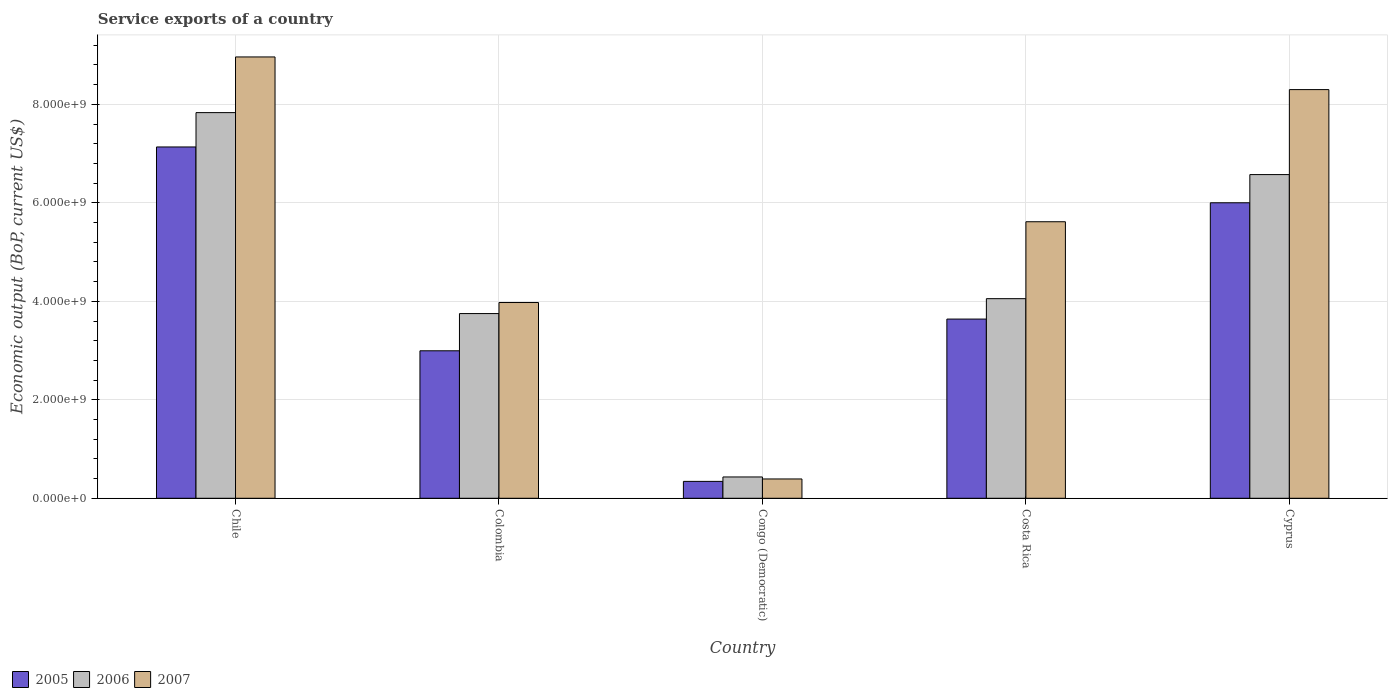How many different coloured bars are there?
Your answer should be very brief. 3. Are the number of bars per tick equal to the number of legend labels?
Provide a succinct answer. Yes. How many bars are there on the 4th tick from the left?
Your answer should be very brief. 3. How many bars are there on the 2nd tick from the right?
Make the answer very short. 3. What is the label of the 5th group of bars from the left?
Keep it short and to the point. Cyprus. In how many cases, is the number of bars for a given country not equal to the number of legend labels?
Give a very brief answer. 0. What is the service exports in 2005 in Cyprus?
Make the answer very short. 6.00e+09. Across all countries, what is the maximum service exports in 2005?
Provide a succinct answer. 7.13e+09. Across all countries, what is the minimum service exports in 2007?
Your answer should be very brief. 3.92e+08. In which country was the service exports in 2005 minimum?
Provide a short and direct response. Congo (Democratic). What is the total service exports in 2007 in the graph?
Offer a very short reply. 2.72e+1. What is the difference between the service exports in 2006 in Colombia and that in Cyprus?
Offer a terse response. -2.82e+09. What is the difference between the service exports in 2007 in Chile and the service exports in 2005 in Cyprus?
Keep it short and to the point. 2.96e+09. What is the average service exports in 2006 per country?
Offer a terse response. 4.53e+09. What is the difference between the service exports of/in 2007 and service exports of/in 2006 in Colombia?
Offer a very short reply. 2.24e+08. In how many countries, is the service exports in 2007 greater than 3200000000 US$?
Your response must be concise. 4. What is the ratio of the service exports in 2007 in Congo (Democratic) to that in Cyprus?
Keep it short and to the point. 0.05. Is the service exports in 2007 in Congo (Democratic) less than that in Cyprus?
Provide a short and direct response. Yes. What is the difference between the highest and the second highest service exports in 2007?
Offer a terse response. 6.63e+08. What is the difference between the highest and the lowest service exports in 2007?
Provide a succinct answer. 8.57e+09. Is the sum of the service exports in 2005 in Congo (Democratic) and Costa Rica greater than the maximum service exports in 2006 across all countries?
Ensure brevity in your answer.  No. Is it the case that in every country, the sum of the service exports in 2006 and service exports in 2005 is greater than the service exports in 2007?
Provide a short and direct response. Yes. How many bars are there?
Keep it short and to the point. 15. Where does the legend appear in the graph?
Make the answer very short. Bottom left. How are the legend labels stacked?
Offer a terse response. Horizontal. What is the title of the graph?
Keep it short and to the point. Service exports of a country. What is the label or title of the Y-axis?
Provide a short and direct response. Economic output (BoP, current US$). What is the Economic output (BoP, current US$) in 2005 in Chile?
Ensure brevity in your answer.  7.13e+09. What is the Economic output (BoP, current US$) in 2006 in Chile?
Ensure brevity in your answer.  7.83e+09. What is the Economic output (BoP, current US$) in 2007 in Chile?
Provide a short and direct response. 8.96e+09. What is the Economic output (BoP, current US$) in 2005 in Colombia?
Offer a very short reply. 3.00e+09. What is the Economic output (BoP, current US$) of 2006 in Colombia?
Offer a terse response. 3.75e+09. What is the Economic output (BoP, current US$) in 2007 in Colombia?
Give a very brief answer. 3.98e+09. What is the Economic output (BoP, current US$) in 2005 in Congo (Democratic)?
Offer a very short reply. 3.43e+08. What is the Economic output (BoP, current US$) in 2006 in Congo (Democratic)?
Provide a short and direct response. 4.33e+08. What is the Economic output (BoP, current US$) in 2007 in Congo (Democratic)?
Give a very brief answer. 3.92e+08. What is the Economic output (BoP, current US$) of 2005 in Costa Rica?
Give a very brief answer. 3.64e+09. What is the Economic output (BoP, current US$) in 2006 in Costa Rica?
Your response must be concise. 4.05e+09. What is the Economic output (BoP, current US$) in 2007 in Costa Rica?
Offer a terse response. 5.62e+09. What is the Economic output (BoP, current US$) of 2005 in Cyprus?
Make the answer very short. 6.00e+09. What is the Economic output (BoP, current US$) in 2006 in Cyprus?
Your response must be concise. 6.57e+09. What is the Economic output (BoP, current US$) in 2007 in Cyprus?
Ensure brevity in your answer.  8.30e+09. Across all countries, what is the maximum Economic output (BoP, current US$) in 2005?
Provide a succinct answer. 7.13e+09. Across all countries, what is the maximum Economic output (BoP, current US$) of 2006?
Ensure brevity in your answer.  7.83e+09. Across all countries, what is the maximum Economic output (BoP, current US$) in 2007?
Make the answer very short. 8.96e+09. Across all countries, what is the minimum Economic output (BoP, current US$) of 2005?
Provide a succinct answer. 3.43e+08. Across all countries, what is the minimum Economic output (BoP, current US$) in 2006?
Provide a short and direct response. 4.33e+08. Across all countries, what is the minimum Economic output (BoP, current US$) of 2007?
Make the answer very short. 3.92e+08. What is the total Economic output (BoP, current US$) of 2005 in the graph?
Keep it short and to the point. 2.01e+1. What is the total Economic output (BoP, current US$) in 2006 in the graph?
Offer a terse response. 2.26e+1. What is the total Economic output (BoP, current US$) in 2007 in the graph?
Ensure brevity in your answer.  2.72e+1. What is the difference between the Economic output (BoP, current US$) in 2005 in Chile and that in Colombia?
Provide a short and direct response. 4.14e+09. What is the difference between the Economic output (BoP, current US$) in 2006 in Chile and that in Colombia?
Give a very brief answer. 4.08e+09. What is the difference between the Economic output (BoP, current US$) in 2007 in Chile and that in Colombia?
Provide a short and direct response. 4.99e+09. What is the difference between the Economic output (BoP, current US$) in 2005 in Chile and that in Congo (Democratic)?
Offer a very short reply. 6.79e+09. What is the difference between the Economic output (BoP, current US$) of 2006 in Chile and that in Congo (Democratic)?
Your response must be concise. 7.40e+09. What is the difference between the Economic output (BoP, current US$) of 2007 in Chile and that in Congo (Democratic)?
Offer a terse response. 8.57e+09. What is the difference between the Economic output (BoP, current US$) in 2005 in Chile and that in Costa Rica?
Offer a very short reply. 3.50e+09. What is the difference between the Economic output (BoP, current US$) of 2006 in Chile and that in Costa Rica?
Offer a very short reply. 3.78e+09. What is the difference between the Economic output (BoP, current US$) in 2007 in Chile and that in Costa Rica?
Your answer should be very brief. 3.35e+09. What is the difference between the Economic output (BoP, current US$) in 2005 in Chile and that in Cyprus?
Provide a succinct answer. 1.13e+09. What is the difference between the Economic output (BoP, current US$) in 2006 in Chile and that in Cyprus?
Offer a very short reply. 1.26e+09. What is the difference between the Economic output (BoP, current US$) of 2007 in Chile and that in Cyprus?
Offer a very short reply. 6.63e+08. What is the difference between the Economic output (BoP, current US$) of 2005 in Colombia and that in Congo (Democratic)?
Ensure brevity in your answer.  2.65e+09. What is the difference between the Economic output (BoP, current US$) of 2006 in Colombia and that in Congo (Democratic)?
Your answer should be very brief. 3.32e+09. What is the difference between the Economic output (BoP, current US$) of 2007 in Colombia and that in Congo (Democratic)?
Provide a short and direct response. 3.58e+09. What is the difference between the Economic output (BoP, current US$) of 2005 in Colombia and that in Costa Rica?
Offer a very short reply. -6.44e+08. What is the difference between the Economic output (BoP, current US$) of 2006 in Colombia and that in Costa Rica?
Give a very brief answer. -3.03e+08. What is the difference between the Economic output (BoP, current US$) in 2007 in Colombia and that in Costa Rica?
Offer a terse response. -1.64e+09. What is the difference between the Economic output (BoP, current US$) of 2005 in Colombia and that in Cyprus?
Keep it short and to the point. -3.01e+09. What is the difference between the Economic output (BoP, current US$) in 2006 in Colombia and that in Cyprus?
Make the answer very short. -2.82e+09. What is the difference between the Economic output (BoP, current US$) of 2007 in Colombia and that in Cyprus?
Your answer should be very brief. -4.32e+09. What is the difference between the Economic output (BoP, current US$) of 2005 in Congo (Democratic) and that in Costa Rica?
Offer a very short reply. -3.30e+09. What is the difference between the Economic output (BoP, current US$) in 2006 in Congo (Democratic) and that in Costa Rica?
Keep it short and to the point. -3.62e+09. What is the difference between the Economic output (BoP, current US$) in 2007 in Congo (Democratic) and that in Costa Rica?
Ensure brevity in your answer.  -5.22e+09. What is the difference between the Economic output (BoP, current US$) in 2005 in Congo (Democratic) and that in Cyprus?
Offer a terse response. -5.66e+09. What is the difference between the Economic output (BoP, current US$) of 2006 in Congo (Democratic) and that in Cyprus?
Offer a very short reply. -6.14e+09. What is the difference between the Economic output (BoP, current US$) in 2007 in Congo (Democratic) and that in Cyprus?
Your response must be concise. -7.91e+09. What is the difference between the Economic output (BoP, current US$) in 2005 in Costa Rica and that in Cyprus?
Make the answer very short. -2.36e+09. What is the difference between the Economic output (BoP, current US$) in 2006 in Costa Rica and that in Cyprus?
Keep it short and to the point. -2.52e+09. What is the difference between the Economic output (BoP, current US$) in 2007 in Costa Rica and that in Cyprus?
Provide a short and direct response. -2.68e+09. What is the difference between the Economic output (BoP, current US$) in 2005 in Chile and the Economic output (BoP, current US$) in 2006 in Colombia?
Make the answer very short. 3.38e+09. What is the difference between the Economic output (BoP, current US$) of 2005 in Chile and the Economic output (BoP, current US$) of 2007 in Colombia?
Make the answer very short. 3.16e+09. What is the difference between the Economic output (BoP, current US$) in 2006 in Chile and the Economic output (BoP, current US$) in 2007 in Colombia?
Keep it short and to the point. 3.86e+09. What is the difference between the Economic output (BoP, current US$) in 2005 in Chile and the Economic output (BoP, current US$) in 2006 in Congo (Democratic)?
Your answer should be compact. 6.70e+09. What is the difference between the Economic output (BoP, current US$) of 2005 in Chile and the Economic output (BoP, current US$) of 2007 in Congo (Democratic)?
Your response must be concise. 6.74e+09. What is the difference between the Economic output (BoP, current US$) of 2006 in Chile and the Economic output (BoP, current US$) of 2007 in Congo (Democratic)?
Offer a terse response. 7.44e+09. What is the difference between the Economic output (BoP, current US$) of 2005 in Chile and the Economic output (BoP, current US$) of 2006 in Costa Rica?
Provide a short and direct response. 3.08e+09. What is the difference between the Economic output (BoP, current US$) in 2005 in Chile and the Economic output (BoP, current US$) in 2007 in Costa Rica?
Offer a very short reply. 1.52e+09. What is the difference between the Economic output (BoP, current US$) of 2006 in Chile and the Economic output (BoP, current US$) of 2007 in Costa Rica?
Offer a terse response. 2.22e+09. What is the difference between the Economic output (BoP, current US$) in 2005 in Chile and the Economic output (BoP, current US$) in 2006 in Cyprus?
Offer a very short reply. 5.61e+08. What is the difference between the Economic output (BoP, current US$) in 2005 in Chile and the Economic output (BoP, current US$) in 2007 in Cyprus?
Ensure brevity in your answer.  -1.16e+09. What is the difference between the Economic output (BoP, current US$) of 2006 in Chile and the Economic output (BoP, current US$) of 2007 in Cyprus?
Provide a succinct answer. -4.67e+08. What is the difference between the Economic output (BoP, current US$) of 2005 in Colombia and the Economic output (BoP, current US$) of 2006 in Congo (Democratic)?
Provide a succinct answer. 2.56e+09. What is the difference between the Economic output (BoP, current US$) of 2005 in Colombia and the Economic output (BoP, current US$) of 2007 in Congo (Democratic)?
Provide a short and direct response. 2.60e+09. What is the difference between the Economic output (BoP, current US$) in 2006 in Colombia and the Economic output (BoP, current US$) in 2007 in Congo (Democratic)?
Offer a very short reply. 3.36e+09. What is the difference between the Economic output (BoP, current US$) in 2005 in Colombia and the Economic output (BoP, current US$) in 2006 in Costa Rica?
Give a very brief answer. -1.06e+09. What is the difference between the Economic output (BoP, current US$) of 2005 in Colombia and the Economic output (BoP, current US$) of 2007 in Costa Rica?
Your response must be concise. -2.62e+09. What is the difference between the Economic output (BoP, current US$) of 2006 in Colombia and the Economic output (BoP, current US$) of 2007 in Costa Rica?
Make the answer very short. -1.86e+09. What is the difference between the Economic output (BoP, current US$) of 2005 in Colombia and the Economic output (BoP, current US$) of 2006 in Cyprus?
Give a very brief answer. -3.58e+09. What is the difference between the Economic output (BoP, current US$) in 2005 in Colombia and the Economic output (BoP, current US$) in 2007 in Cyprus?
Give a very brief answer. -5.30e+09. What is the difference between the Economic output (BoP, current US$) of 2006 in Colombia and the Economic output (BoP, current US$) of 2007 in Cyprus?
Provide a short and direct response. -4.55e+09. What is the difference between the Economic output (BoP, current US$) of 2005 in Congo (Democratic) and the Economic output (BoP, current US$) of 2006 in Costa Rica?
Make the answer very short. -3.71e+09. What is the difference between the Economic output (BoP, current US$) of 2005 in Congo (Democratic) and the Economic output (BoP, current US$) of 2007 in Costa Rica?
Ensure brevity in your answer.  -5.27e+09. What is the difference between the Economic output (BoP, current US$) in 2006 in Congo (Democratic) and the Economic output (BoP, current US$) in 2007 in Costa Rica?
Make the answer very short. -5.18e+09. What is the difference between the Economic output (BoP, current US$) in 2005 in Congo (Democratic) and the Economic output (BoP, current US$) in 2006 in Cyprus?
Keep it short and to the point. -6.23e+09. What is the difference between the Economic output (BoP, current US$) in 2005 in Congo (Democratic) and the Economic output (BoP, current US$) in 2007 in Cyprus?
Provide a succinct answer. -7.96e+09. What is the difference between the Economic output (BoP, current US$) in 2006 in Congo (Democratic) and the Economic output (BoP, current US$) in 2007 in Cyprus?
Offer a very short reply. -7.87e+09. What is the difference between the Economic output (BoP, current US$) of 2005 in Costa Rica and the Economic output (BoP, current US$) of 2006 in Cyprus?
Offer a very short reply. -2.93e+09. What is the difference between the Economic output (BoP, current US$) of 2005 in Costa Rica and the Economic output (BoP, current US$) of 2007 in Cyprus?
Ensure brevity in your answer.  -4.66e+09. What is the difference between the Economic output (BoP, current US$) of 2006 in Costa Rica and the Economic output (BoP, current US$) of 2007 in Cyprus?
Your answer should be compact. -4.25e+09. What is the average Economic output (BoP, current US$) of 2005 per country?
Your answer should be compact. 4.02e+09. What is the average Economic output (BoP, current US$) of 2006 per country?
Your answer should be compact. 4.53e+09. What is the average Economic output (BoP, current US$) of 2007 per country?
Your response must be concise. 5.45e+09. What is the difference between the Economic output (BoP, current US$) in 2005 and Economic output (BoP, current US$) in 2006 in Chile?
Ensure brevity in your answer.  -6.97e+08. What is the difference between the Economic output (BoP, current US$) in 2005 and Economic output (BoP, current US$) in 2007 in Chile?
Your answer should be very brief. -1.83e+09. What is the difference between the Economic output (BoP, current US$) of 2006 and Economic output (BoP, current US$) of 2007 in Chile?
Your response must be concise. -1.13e+09. What is the difference between the Economic output (BoP, current US$) in 2005 and Economic output (BoP, current US$) in 2006 in Colombia?
Ensure brevity in your answer.  -7.56e+08. What is the difference between the Economic output (BoP, current US$) of 2005 and Economic output (BoP, current US$) of 2007 in Colombia?
Your response must be concise. -9.80e+08. What is the difference between the Economic output (BoP, current US$) in 2006 and Economic output (BoP, current US$) in 2007 in Colombia?
Your response must be concise. -2.24e+08. What is the difference between the Economic output (BoP, current US$) of 2005 and Economic output (BoP, current US$) of 2006 in Congo (Democratic)?
Keep it short and to the point. -8.97e+07. What is the difference between the Economic output (BoP, current US$) in 2005 and Economic output (BoP, current US$) in 2007 in Congo (Democratic)?
Make the answer very short. -4.92e+07. What is the difference between the Economic output (BoP, current US$) of 2006 and Economic output (BoP, current US$) of 2007 in Congo (Democratic)?
Your response must be concise. 4.05e+07. What is the difference between the Economic output (BoP, current US$) in 2005 and Economic output (BoP, current US$) in 2006 in Costa Rica?
Keep it short and to the point. -4.14e+08. What is the difference between the Economic output (BoP, current US$) in 2005 and Economic output (BoP, current US$) in 2007 in Costa Rica?
Your response must be concise. -1.98e+09. What is the difference between the Economic output (BoP, current US$) in 2006 and Economic output (BoP, current US$) in 2007 in Costa Rica?
Make the answer very short. -1.56e+09. What is the difference between the Economic output (BoP, current US$) in 2005 and Economic output (BoP, current US$) in 2006 in Cyprus?
Ensure brevity in your answer.  -5.72e+08. What is the difference between the Economic output (BoP, current US$) in 2005 and Economic output (BoP, current US$) in 2007 in Cyprus?
Offer a very short reply. -2.30e+09. What is the difference between the Economic output (BoP, current US$) of 2006 and Economic output (BoP, current US$) of 2007 in Cyprus?
Provide a succinct answer. -1.73e+09. What is the ratio of the Economic output (BoP, current US$) in 2005 in Chile to that in Colombia?
Offer a terse response. 2.38. What is the ratio of the Economic output (BoP, current US$) in 2006 in Chile to that in Colombia?
Keep it short and to the point. 2.09. What is the ratio of the Economic output (BoP, current US$) in 2007 in Chile to that in Colombia?
Keep it short and to the point. 2.25. What is the ratio of the Economic output (BoP, current US$) in 2005 in Chile to that in Congo (Democratic)?
Offer a very short reply. 20.79. What is the ratio of the Economic output (BoP, current US$) of 2006 in Chile to that in Congo (Democratic)?
Keep it short and to the point. 18.09. What is the ratio of the Economic output (BoP, current US$) in 2007 in Chile to that in Congo (Democratic)?
Offer a terse response. 22.84. What is the ratio of the Economic output (BoP, current US$) in 2005 in Chile to that in Costa Rica?
Make the answer very short. 1.96. What is the ratio of the Economic output (BoP, current US$) of 2006 in Chile to that in Costa Rica?
Provide a short and direct response. 1.93. What is the ratio of the Economic output (BoP, current US$) of 2007 in Chile to that in Costa Rica?
Provide a succinct answer. 1.6. What is the ratio of the Economic output (BoP, current US$) of 2005 in Chile to that in Cyprus?
Offer a terse response. 1.19. What is the ratio of the Economic output (BoP, current US$) in 2006 in Chile to that in Cyprus?
Make the answer very short. 1.19. What is the ratio of the Economic output (BoP, current US$) in 2007 in Chile to that in Cyprus?
Keep it short and to the point. 1.08. What is the ratio of the Economic output (BoP, current US$) in 2005 in Colombia to that in Congo (Democratic)?
Your response must be concise. 8.73. What is the ratio of the Economic output (BoP, current US$) in 2006 in Colombia to that in Congo (Democratic)?
Offer a terse response. 8.67. What is the ratio of the Economic output (BoP, current US$) of 2007 in Colombia to that in Congo (Democratic)?
Make the answer very short. 10.13. What is the ratio of the Economic output (BoP, current US$) in 2005 in Colombia to that in Costa Rica?
Provide a short and direct response. 0.82. What is the ratio of the Economic output (BoP, current US$) of 2006 in Colombia to that in Costa Rica?
Your answer should be very brief. 0.93. What is the ratio of the Economic output (BoP, current US$) in 2007 in Colombia to that in Costa Rica?
Offer a very short reply. 0.71. What is the ratio of the Economic output (BoP, current US$) of 2005 in Colombia to that in Cyprus?
Provide a succinct answer. 0.5. What is the ratio of the Economic output (BoP, current US$) of 2006 in Colombia to that in Cyprus?
Give a very brief answer. 0.57. What is the ratio of the Economic output (BoP, current US$) in 2007 in Colombia to that in Cyprus?
Your response must be concise. 0.48. What is the ratio of the Economic output (BoP, current US$) of 2005 in Congo (Democratic) to that in Costa Rica?
Ensure brevity in your answer.  0.09. What is the ratio of the Economic output (BoP, current US$) of 2006 in Congo (Democratic) to that in Costa Rica?
Make the answer very short. 0.11. What is the ratio of the Economic output (BoP, current US$) of 2007 in Congo (Democratic) to that in Costa Rica?
Ensure brevity in your answer.  0.07. What is the ratio of the Economic output (BoP, current US$) of 2005 in Congo (Democratic) to that in Cyprus?
Your answer should be very brief. 0.06. What is the ratio of the Economic output (BoP, current US$) in 2006 in Congo (Democratic) to that in Cyprus?
Provide a succinct answer. 0.07. What is the ratio of the Economic output (BoP, current US$) of 2007 in Congo (Democratic) to that in Cyprus?
Provide a succinct answer. 0.05. What is the ratio of the Economic output (BoP, current US$) of 2005 in Costa Rica to that in Cyprus?
Give a very brief answer. 0.61. What is the ratio of the Economic output (BoP, current US$) of 2006 in Costa Rica to that in Cyprus?
Your answer should be compact. 0.62. What is the ratio of the Economic output (BoP, current US$) in 2007 in Costa Rica to that in Cyprus?
Your answer should be compact. 0.68. What is the difference between the highest and the second highest Economic output (BoP, current US$) of 2005?
Offer a very short reply. 1.13e+09. What is the difference between the highest and the second highest Economic output (BoP, current US$) in 2006?
Your answer should be very brief. 1.26e+09. What is the difference between the highest and the second highest Economic output (BoP, current US$) in 2007?
Give a very brief answer. 6.63e+08. What is the difference between the highest and the lowest Economic output (BoP, current US$) of 2005?
Give a very brief answer. 6.79e+09. What is the difference between the highest and the lowest Economic output (BoP, current US$) in 2006?
Offer a terse response. 7.40e+09. What is the difference between the highest and the lowest Economic output (BoP, current US$) in 2007?
Ensure brevity in your answer.  8.57e+09. 